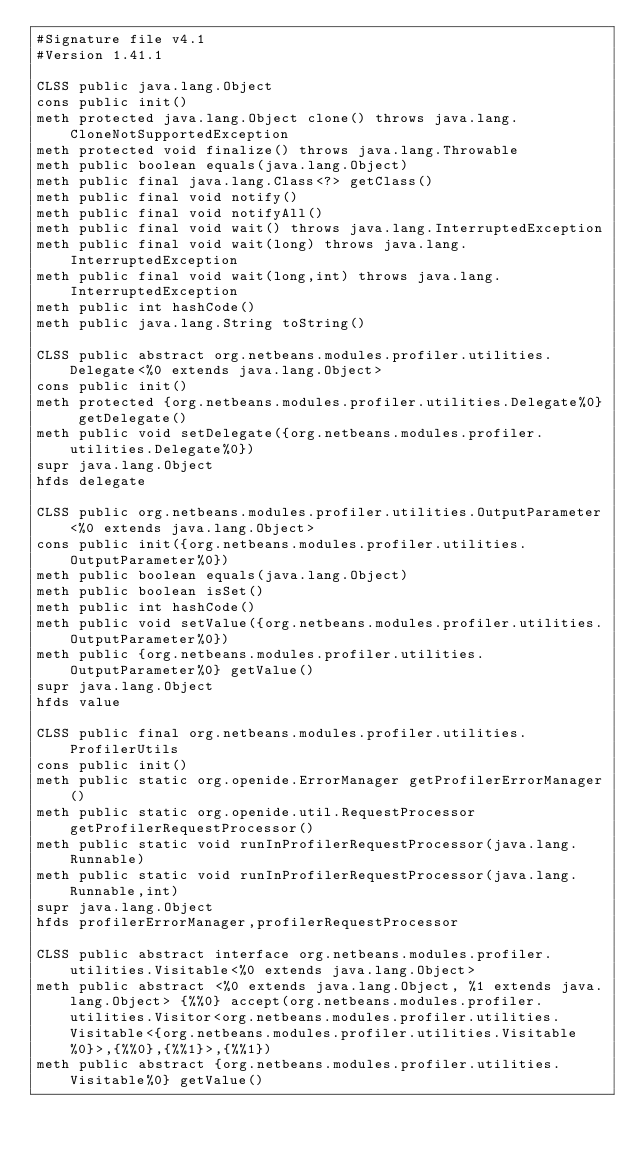<code> <loc_0><loc_0><loc_500><loc_500><_SML_>#Signature file v4.1
#Version 1.41.1

CLSS public java.lang.Object
cons public init()
meth protected java.lang.Object clone() throws java.lang.CloneNotSupportedException
meth protected void finalize() throws java.lang.Throwable
meth public boolean equals(java.lang.Object)
meth public final java.lang.Class<?> getClass()
meth public final void notify()
meth public final void notifyAll()
meth public final void wait() throws java.lang.InterruptedException
meth public final void wait(long) throws java.lang.InterruptedException
meth public final void wait(long,int) throws java.lang.InterruptedException
meth public int hashCode()
meth public java.lang.String toString()

CLSS public abstract org.netbeans.modules.profiler.utilities.Delegate<%0 extends java.lang.Object>
cons public init()
meth protected {org.netbeans.modules.profiler.utilities.Delegate%0} getDelegate()
meth public void setDelegate({org.netbeans.modules.profiler.utilities.Delegate%0})
supr java.lang.Object
hfds delegate

CLSS public org.netbeans.modules.profiler.utilities.OutputParameter<%0 extends java.lang.Object>
cons public init({org.netbeans.modules.profiler.utilities.OutputParameter%0})
meth public boolean equals(java.lang.Object)
meth public boolean isSet()
meth public int hashCode()
meth public void setValue({org.netbeans.modules.profiler.utilities.OutputParameter%0})
meth public {org.netbeans.modules.profiler.utilities.OutputParameter%0} getValue()
supr java.lang.Object
hfds value

CLSS public final org.netbeans.modules.profiler.utilities.ProfilerUtils
cons public init()
meth public static org.openide.ErrorManager getProfilerErrorManager()
meth public static org.openide.util.RequestProcessor getProfilerRequestProcessor()
meth public static void runInProfilerRequestProcessor(java.lang.Runnable)
meth public static void runInProfilerRequestProcessor(java.lang.Runnable,int)
supr java.lang.Object
hfds profilerErrorManager,profilerRequestProcessor

CLSS public abstract interface org.netbeans.modules.profiler.utilities.Visitable<%0 extends java.lang.Object>
meth public abstract <%0 extends java.lang.Object, %1 extends java.lang.Object> {%%0} accept(org.netbeans.modules.profiler.utilities.Visitor<org.netbeans.modules.profiler.utilities.Visitable<{org.netbeans.modules.profiler.utilities.Visitable%0}>,{%%0},{%%1}>,{%%1})
meth public abstract {org.netbeans.modules.profiler.utilities.Visitable%0} getValue()
</code> 